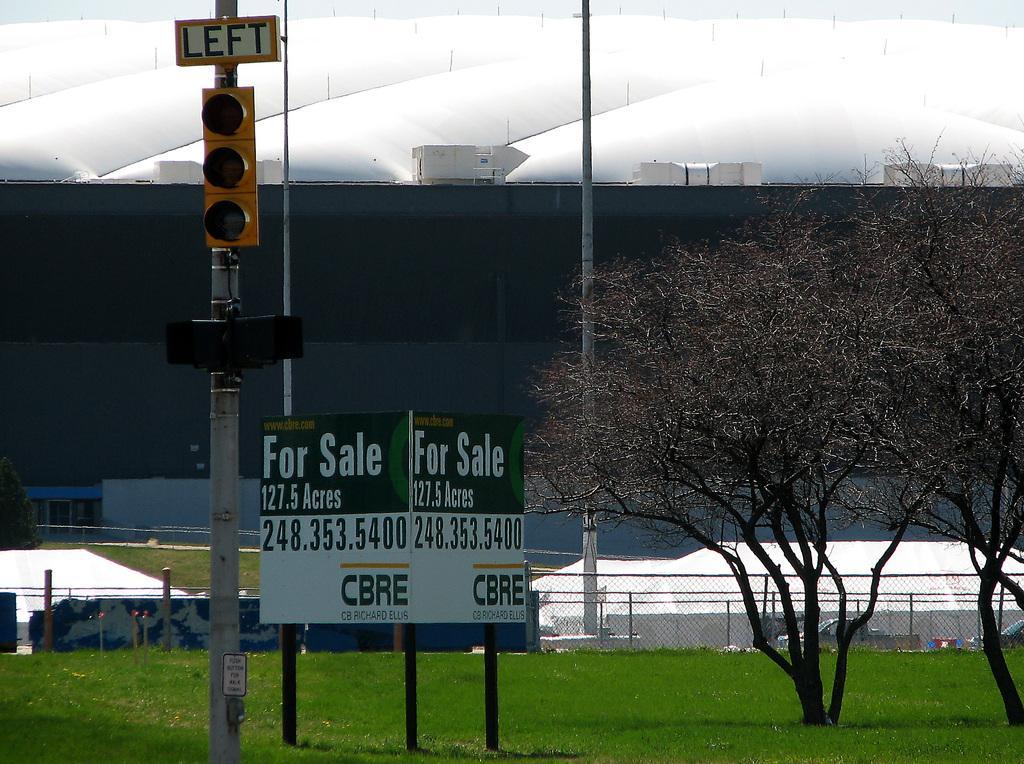Can you describe this image briefly? In the picture we can see a grass surface on it, we can see a board with the advertisement of land sale and beside it, we can see a pole with traffic light and besides we can see some trees and poles behind it with a railing. 